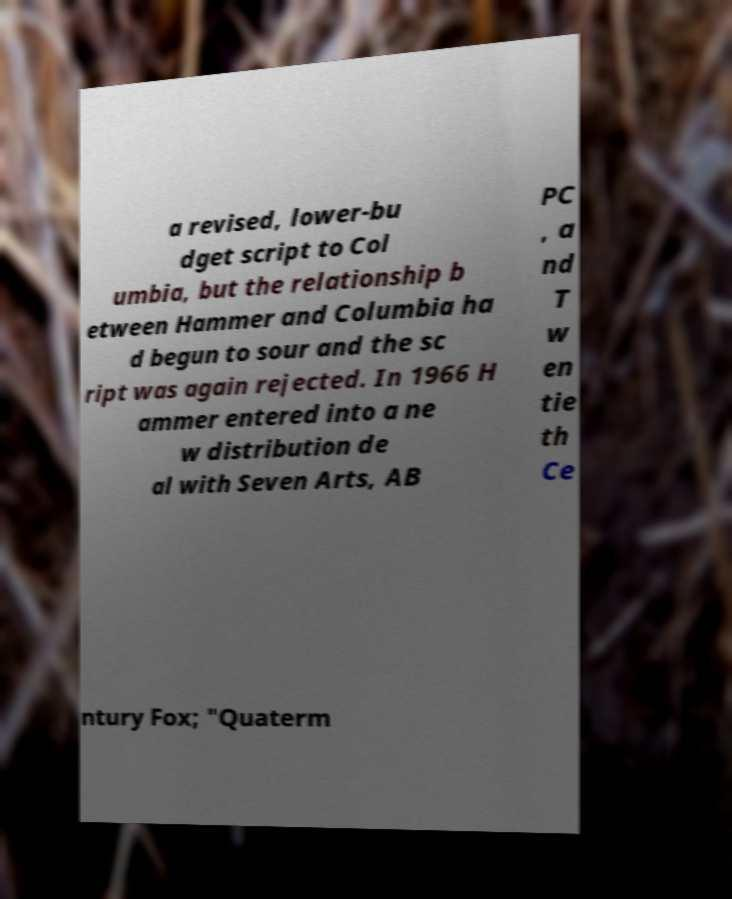What messages or text are displayed in this image? I need them in a readable, typed format. a revised, lower-bu dget script to Col umbia, but the relationship b etween Hammer and Columbia ha d begun to sour and the sc ript was again rejected. In 1966 H ammer entered into a ne w distribution de al with Seven Arts, AB PC , a nd T w en tie th Ce ntury Fox; "Quaterm 